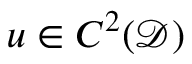Convert formula to latex. <formula><loc_0><loc_0><loc_500><loc_500>u \in C ^ { 2 } ( \mathcal { D } )</formula> 